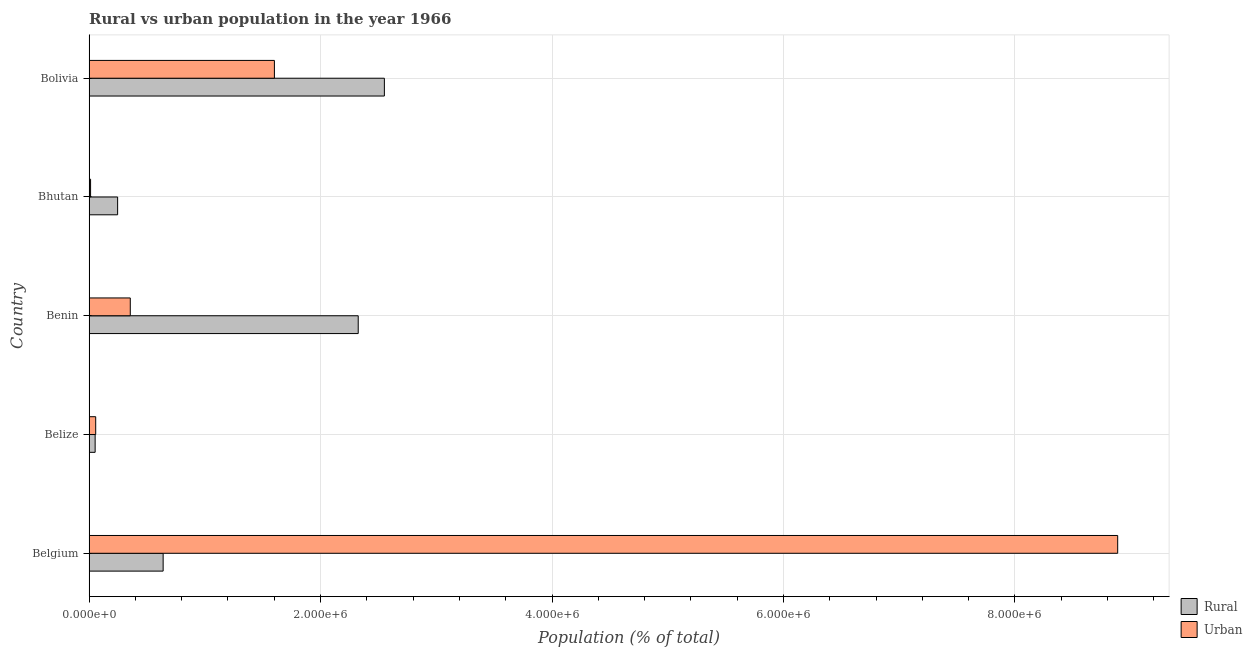How many different coloured bars are there?
Your answer should be very brief. 2. How many groups of bars are there?
Ensure brevity in your answer.  5. How many bars are there on the 3rd tick from the bottom?
Your response must be concise. 2. What is the label of the 5th group of bars from the top?
Provide a succinct answer. Belgium. What is the rural population density in Belgium?
Keep it short and to the point. 6.40e+05. Across all countries, what is the maximum urban population density?
Keep it short and to the point. 8.89e+06. Across all countries, what is the minimum urban population density?
Offer a terse response. 1.28e+04. In which country was the rural population density maximum?
Your response must be concise. Bolivia. In which country was the rural population density minimum?
Offer a very short reply. Belize. What is the total urban population density in the graph?
Offer a terse response. 1.09e+07. What is the difference between the rural population density in Belgium and that in Bolivia?
Provide a succinct answer. -1.91e+06. What is the difference between the rural population density in Belgium and the urban population density in Belize?
Provide a succinct answer. 5.83e+05. What is the average urban population density per country?
Ensure brevity in your answer.  2.18e+06. What is the difference between the urban population density and rural population density in Bhutan?
Ensure brevity in your answer.  -2.34e+05. What is the ratio of the rural population density in Belize to that in Bhutan?
Offer a very short reply. 0.21. Is the urban population density in Belgium less than that in Bolivia?
Offer a terse response. No. What is the difference between the highest and the second highest rural population density?
Make the answer very short. 2.26e+05. What is the difference between the highest and the lowest urban population density?
Your answer should be very brief. 8.88e+06. What does the 2nd bar from the top in Belgium represents?
Ensure brevity in your answer.  Rural. What does the 2nd bar from the bottom in Benin represents?
Your answer should be very brief. Urban. How many bars are there?
Your response must be concise. 10. What is the difference between two consecutive major ticks on the X-axis?
Make the answer very short. 2.00e+06. Are the values on the major ticks of X-axis written in scientific E-notation?
Provide a short and direct response. Yes. Does the graph contain any zero values?
Keep it short and to the point. No. Does the graph contain grids?
Provide a succinct answer. Yes. Where does the legend appear in the graph?
Provide a short and direct response. Bottom right. What is the title of the graph?
Provide a succinct answer. Rural vs urban population in the year 1966. What is the label or title of the X-axis?
Provide a short and direct response. Population (% of total). What is the Population (% of total) in Rural in Belgium?
Your response must be concise. 6.40e+05. What is the Population (% of total) of Urban in Belgium?
Your answer should be compact. 8.89e+06. What is the Population (% of total) of Rural in Belize?
Make the answer very short. 5.23e+04. What is the Population (% of total) in Urban in Belize?
Your response must be concise. 5.70e+04. What is the Population (% of total) of Rural in Benin?
Your response must be concise. 2.33e+06. What is the Population (% of total) in Urban in Benin?
Offer a very short reply. 3.56e+05. What is the Population (% of total) in Rural in Bhutan?
Provide a short and direct response. 2.46e+05. What is the Population (% of total) in Urban in Bhutan?
Make the answer very short. 1.28e+04. What is the Population (% of total) in Rural in Bolivia?
Your answer should be compact. 2.55e+06. What is the Population (% of total) in Urban in Bolivia?
Make the answer very short. 1.60e+06. Across all countries, what is the maximum Population (% of total) of Rural?
Offer a very short reply. 2.55e+06. Across all countries, what is the maximum Population (% of total) in Urban?
Make the answer very short. 8.89e+06. Across all countries, what is the minimum Population (% of total) in Rural?
Make the answer very short. 5.23e+04. Across all countries, what is the minimum Population (% of total) of Urban?
Provide a succinct answer. 1.28e+04. What is the total Population (% of total) of Rural in the graph?
Your answer should be compact. 5.82e+06. What is the total Population (% of total) in Urban in the graph?
Ensure brevity in your answer.  1.09e+07. What is the difference between the Population (% of total) in Rural in Belgium and that in Belize?
Offer a very short reply. 5.88e+05. What is the difference between the Population (% of total) of Urban in Belgium and that in Belize?
Offer a terse response. 8.83e+06. What is the difference between the Population (% of total) in Rural in Belgium and that in Benin?
Your response must be concise. -1.69e+06. What is the difference between the Population (% of total) in Urban in Belgium and that in Benin?
Give a very brief answer. 8.53e+06. What is the difference between the Population (% of total) in Rural in Belgium and that in Bhutan?
Give a very brief answer. 3.93e+05. What is the difference between the Population (% of total) in Urban in Belgium and that in Bhutan?
Your answer should be very brief. 8.88e+06. What is the difference between the Population (% of total) in Rural in Belgium and that in Bolivia?
Your answer should be very brief. -1.91e+06. What is the difference between the Population (% of total) of Urban in Belgium and that in Bolivia?
Your answer should be compact. 7.29e+06. What is the difference between the Population (% of total) in Rural in Belize and that in Benin?
Offer a very short reply. -2.27e+06. What is the difference between the Population (% of total) of Urban in Belize and that in Benin?
Provide a short and direct response. -2.99e+05. What is the difference between the Population (% of total) of Rural in Belize and that in Bhutan?
Your answer should be compact. -1.94e+05. What is the difference between the Population (% of total) of Urban in Belize and that in Bhutan?
Keep it short and to the point. 4.42e+04. What is the difference between the Population (% of total) of Rural in Belize and that in Bolivia?
Offer a terse response. -2.50e+06. What is the difference between the Population (% of total) of Urban in Belize and that in Bolivia?
Give a very brief answer. -1.54e+06. What is the difference between the Population (% of total) of Rural in Benin and that in Bhutan?
Your response must be concise. 2.08e+06. What is the difference between the Population (% of total) in Urban in Benin and that in Bhutan?
Your answer should be compact. 3.43e+05. What is the difference between the Population (% of total) of Rural in Benin and that in Bolivia?
Offer a very short reply. -2.26e+05. What is the difference between the Population (% of total) of Urban in Benin and that in Bolivia?
Ensure brevity in your answer.  -1.25e+06. What is the difference between the Population (% of total) of Rural in Bhutan and that in Bolivia?
Give a very brief answer. -2.30e+06. What is the difference between the Population (% of total) of Urban in Bhutan and that in Bolivia?
Your response must be concise. -1.59e+06. What is the difference between the Population (% of total) in Rural in Belgium and the Population (% of total) in Urban in Belize?
Make the answer very short. 5.83e+05. What is the difference between the Population (% of total) of Rural in Belgium and the Population (% of total) of Urban in Benin?
Keep it short and to the point. 2.84e+05. What is the difference between the Population (% of total) in Rural in Belgium and the Population (% of total) in Urban in Bhutan?
Your answer should be compact. 6.27e+05. What is the difference between the Population (% of total) in Rural in Belgium and the Population (% of total) in Urban in Bolivia?
Provide a succinct answer. -9.61e+05. What is the difference between the Population (% of total) in Rural in Belize and the Population (% of total) in Urban in Benin?
Offer a terse response. -3.04e+05. What is the difference between the Population (% of total) in Rural in Belize and the Population (% of total) in Urban in Bhutan?
Your answer should be very brief. 3.95e+04. What is the difference between the Population (% of total) of Rural in Belize and the Population (% of total) of Urban in Bolivia?
Your answer should be very brief. -1.55e+06. What is the difference between the Population (% of total) in Rural in Benin and the Population (% of total) in Urban in Bhutan?
Keep it short and to the point. 2.31e+06. What is the difference between the Population (% of total) of Rural in Benin and the Population (% of total) of Urban in Bolivia?
Your response must be concise. 7.24e+05. What is the difference between the Population (% of total) in Rural in Bhutan and the Population (% of total) in Urban in Bolivia?
Provide a short and direct response. -1.35e+06. What is the average Population (% of total) in Rural per country?
Your answer should be compact. 1.16e+06. What is the average Population (% of total) in Urban per country?
Provide a short and direct response. 2.18e+06. What is the difference between the Population (% of total) of Rural and Population (% of total) of Urban in Belgium?
Make the answer very short. -8.25e+06. What is the difference between the Population (% of total) in Rural and Population (% of total) in Urban in Belize?
Your response must be concise. -4746. What is the difference between the Population (% of total) of Rural and Population (% of total) of Urban in Benin?
Your response must be concise. 1.97e+06. What is the difference between the Population (% of total) of Rural and Population (% of total) of Urban in Bhutan?
Ensure brevity in your answer.  2.34e+05. What is the difference between the Population (% of total) of Rural and Population (% of total) of Urban in Bolivia?
Your answer should be compact. 9.50e+05. What is the ratio of the Population (% of total) in Rural in Belgium to that in Belize?
Make the answer very short. 12.24. What is the ratio of the Population (% of total) in Urban in Belgium to that in Belize?
Your answer should be compact. 155.81. What is the ratio of the Population (% of total) of Rural in Belgium to that in Benin?
Provide a short and direct response. 0.28. What is the ratio of the Population (% of total) of Urban in Belgium to that in Benin?
Provide a short and direct response. 24.97. What is the ratio of the Population (% of total) in Rural in Belgium to that in Bhutan?
Offer a terse response. 2.6. What is the ratio of the Population (% of total) in Urban in Belgium to that in Bhutan?
Your answer should be compact. 693.93. What is the ratio of the Population (% of total) in Rural in Belgium to that in Bolivia?
Give a very brief answer. 0.25. What is the ratio of the Population (% of total) in Urban in Belgium to that in Bolivia?
Ensure brevity in your answer.  5.55. What is the ratio of the Population (% of total) of Rural in Belize to that in Benin?
Provide a succinct answer. 0.02. What is the ratio of the Population (% of total) of Urban in Belize to that in Benin?
Make the answer very short. 0.16. What is the ratio of the Population (% of total) in Rural in Belize to that in Bhutan?
Keep it short and to the point. 0.21. What is the ratio of the Population (% of total) in Urban in Belize to that in Bhutan?
Make the answer very short. 4.45. What is the ratio of the Population (% of total) of Rural in Belize to that in Bolivia?
Keep it short and to the point. 0.02. What is the ratio of the Population (% of total) in Urban in Belize to that in Bolivia?
Keep it short and to the point. 0.04. What is the ratio of the Population (% of total) of Rural in Benin to that in Bhutan?
Offer a terse response. 9.44. What is the ratio of the Population (% of total) of Urban in Benin to that in Bhutan?
Provide a succinct answer. 27.79. What is the ratio of the Population (% of total) of Rural in Benin to that in Bolivia?
Provide a succinct answer. 0.91. What is the ratio of the Population (% of total) in Urban in Benin to that in Bolivia?
Offer a terse response. 0.22. What is the ratio of the Population (% of total) in Rural in Bhutan to that in Bolivia?
Your answer should be compact. 0.1. What is the ratio of the Population (% of total) of Urban in Bhutan to that in Bolivia?
Your answer should be compact. 0.01. What is the difference between the highest and the second highest Population (% of total) of Rural?
Give a very brief answer. 2.26e+05. What is the difference between the highest and the second highest Population (% of total) of Urban?
Offer a very short reply. 7.29e+06. What is the difference between the highest and the lowest Population (% of total) of Rural?
Your answer should be compact. 2.50e+06. What is the difference between the highest and the lowest Population (% of total) of Urban?
Your response must be concise. 8.88e+06. 